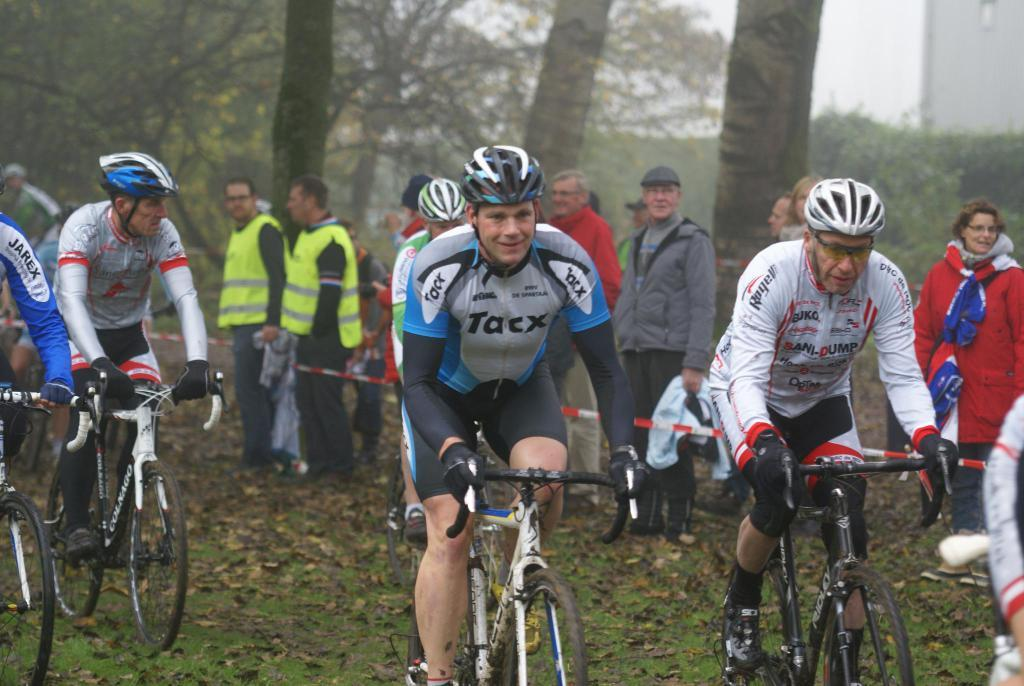What is the main subject of the image? The main subject of the image is a crowd of people. What are some of the people in the crowd doing? Some people in the crowd are riding bicycles, while others are standing on the ground. What can be seen in the background of the image? Trees and the sky are visible in the background of the image. What type of ground cover can be seen in the image? Shredded leaves are present in the image. What type of ghost can be seen interacting with the crowd in the image? There is no ghost present in the image, and therefore no such interaction can be observed. 